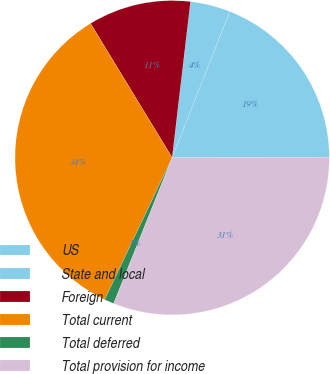Convert chart to OTSL. <chart><loc_0><loc_0><loc_500><loc_500><pie_chart><fcel>US<fcel>State and local<fcel>Foreign<fcel>Total current<fcel>Total deferred<fcel>Total provision for income<nl><fcel>18.97%<fcel>4.11%<fcel>10.56%<fcel>34.23%<fcel>1.0%<fcel>31.12%<nl></chart> 